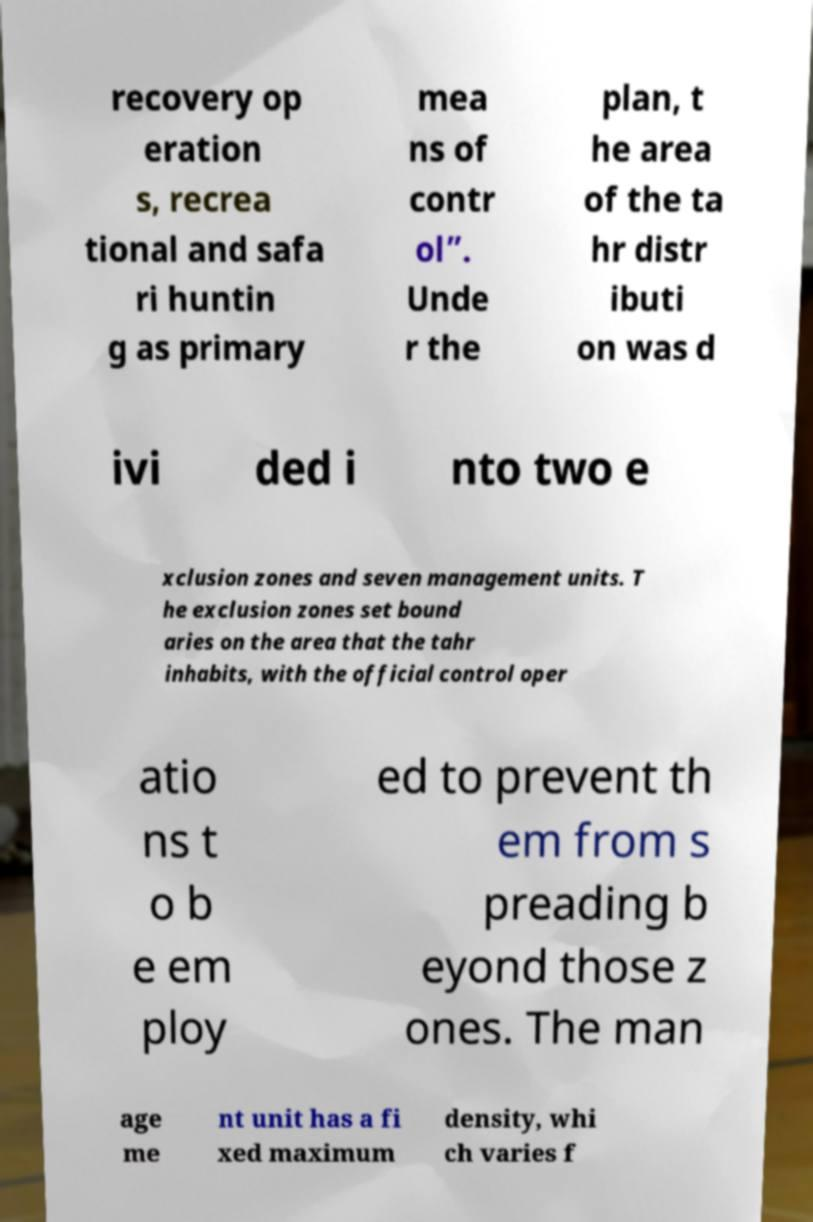What messages or text are displayed in this image? I need them in a readable, typed format. recovery op eration s, recrea tional and safa ri huntin g as primary mea ns of contr ol”. Unde r the plan, t he area of the ta hr distr ibuti on was d ivi ded i nto two e xclusion zones and seven management units. T he exclusion zones set bound aries on the area that the tahr inhabits, with the official control oper atio ns t o b e em ploy ed to prevent th em from s preading b eyond those z ones. The man age me nt unit has a fi xed maximum density, whi ch varies f 